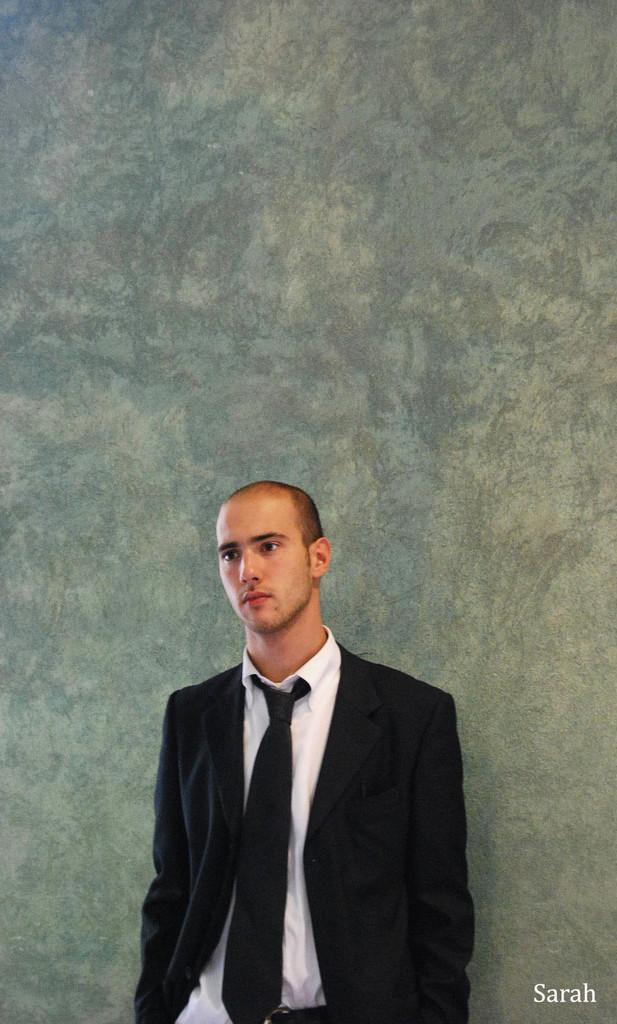Who is the main subject in the image? There is a man in the image. What is the man wearing on his upper body? The man is wearing a black coat and a white shirt. What is the man doing in the image? The man is standing and posing for the camera. What can be seen on the wall in the background? There is grey wallpaper on the wall in the background. What type of collar is visible on the arm of the man in the image? There is no arm or collar visible on the man in the image; he is wearing a black coat and a white shirt. 